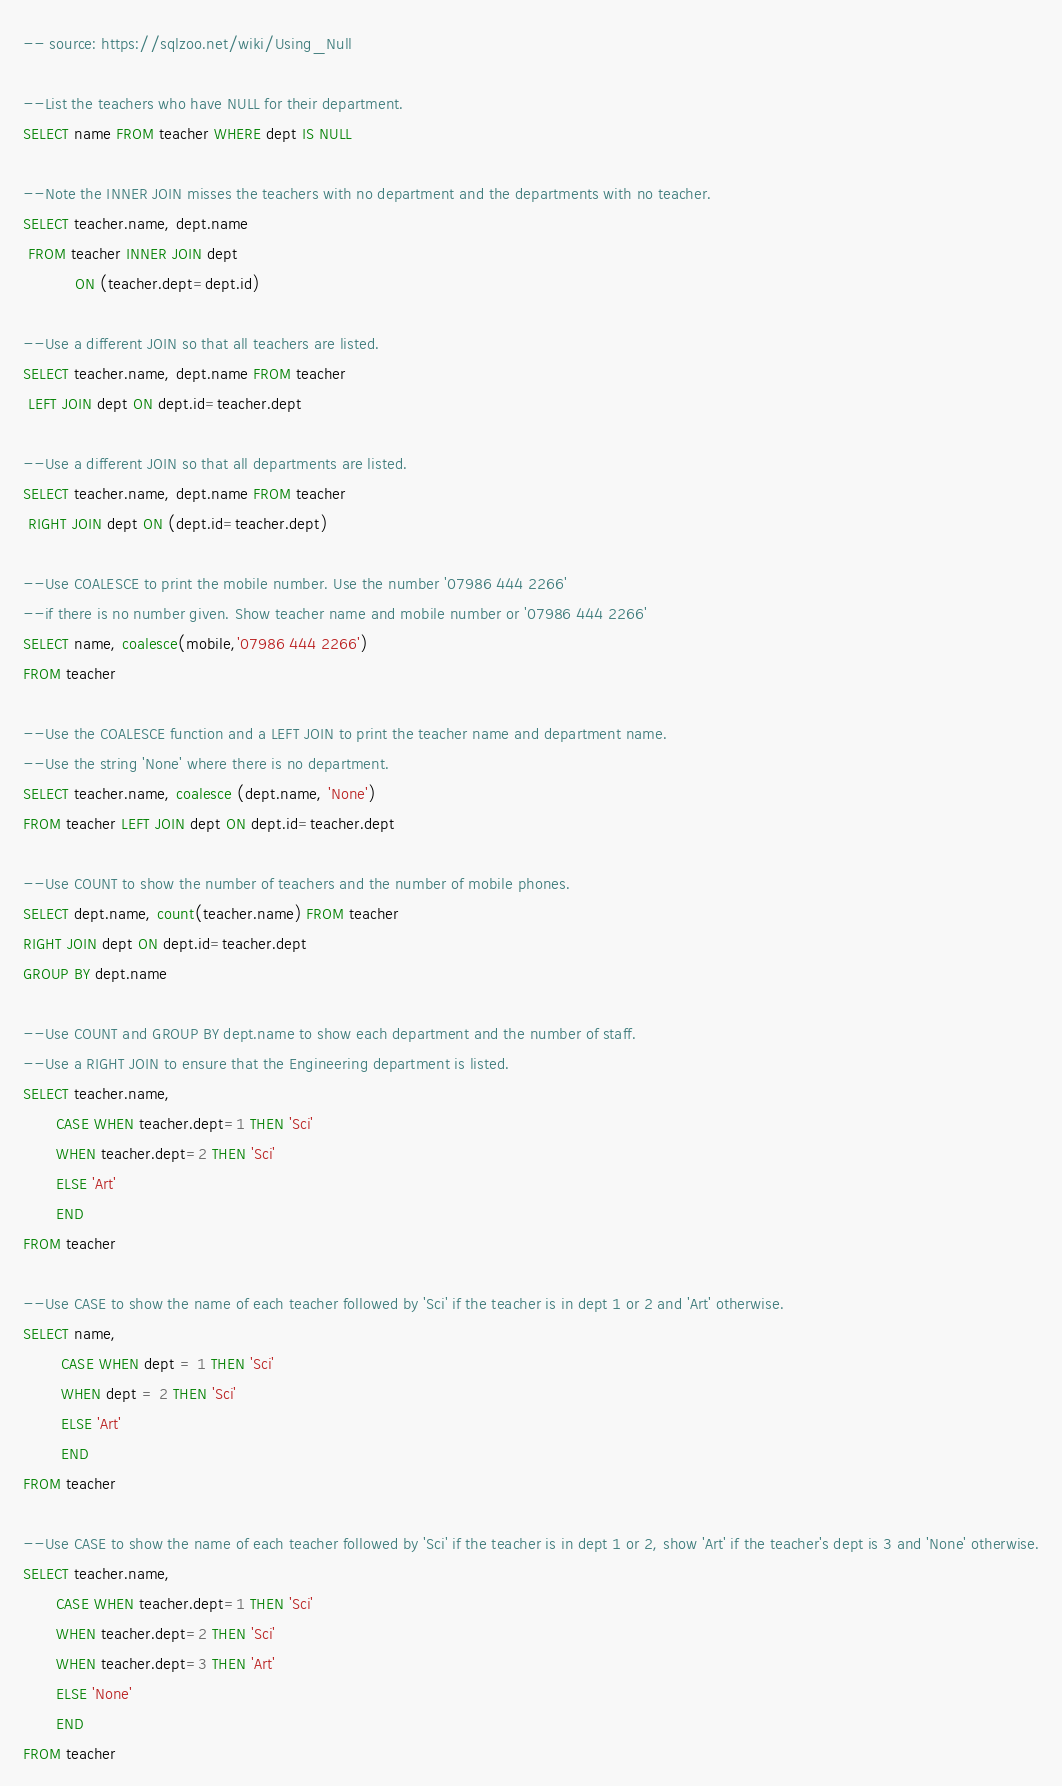<code> <loc_0><loc_0><loc_500><loc_500><_SQL_>-- source: https://sqlzoo.net/wiki/Using_Null

--List the teachers who have NULL for their department.
SELECT name FROM teacher WHERE dept IS NULL

--Note the INNER JOIN misses the teachers with no department and the departments with no teacher.
SELECT teacher.name, dept.name
 FROM teacher INNER JOIN dept
           ON (teacher.dept=dept.id)

--Use a different JOIN so that all teachers are listed.
SELECT teacher.name, dept.name FROM teacher
 LEFT JOIN dept ON dept.id=teacher.dept

--Use a different JOIN so that all departments are listed.
SELECT teacher.name, dept.name FROM teacher
 RIGHT JOIN dept ON (dept.id=teacher.dept)

--Use COALESCE to print the mobile number. Use the number '07986 444 2266' 
--if there is no number given. Show teacher name and mobile number or '07986 444 2266'
SELECT name, coalesce(mobile,'07986 444 2266')
FROM teacher

--Use the COALESCE function and a LEFT JOIN to print the teacher name and department name. 
--Use the string 'None' where there is no department.
SELECT teacher.name, coalesce (dept.name, 'None') 
FROM teacher LEFT JOIN dept ON dept.id=teacher.dept

--Use COUNT to show the number of teachers and the number of mobile phones.
SELECT dept.name, count(teacher.name) FROM teacher 
RIGHT JOIN dept ON dept.id=teacher.dept
GROUP BY dept.name

--Use COUNT and GROUP BY dept.name to show each department and the number of staff. 
--Use a RIGHT JOIN to ensure that the Engineering department is listed.
SELECT teacher.name,
       CASE WHEN teacher.dept=1 THEN 'Sci' 
       WHEN teacher.dept=2 THEN 'Sci' 
       ELSE 'Art'
       END
FROM teacher

--Use CASE to show the name of each teacher followed by 'Sci' if the teacher is in dept 1 or 2 and 'Art' otherwise.
SELECT name, 
        CASE WHEN dept = 1 THEN 'Sci'
        WHEN dept = 2 THEN 'Sci'
        ELSE 'Art'
        END
FROM teacher

--Use CASE to show the name of each teacher followed by 'Sci' if the teacher is in dept 1 or 2, show 'Art' if the teacher's dept is 3 and 'None' otherwise.
SELECT teacher.name, 
       CASE WHEN teacher.dept=1 THEN 'Sci'
       WHEN teacher.dept=2 THEN 'Sci'
       WHEN teacher.dept=3 THEN 'Art'
       ELSE 'None'
       END
FROM teacher
</code> 